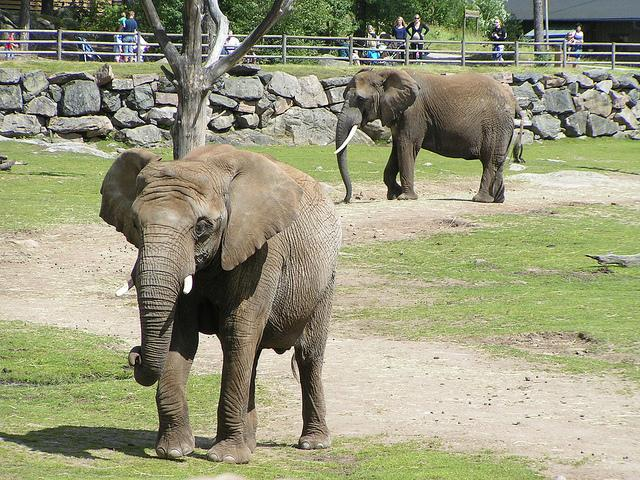At which elevation are the elephants compared to those looking at them?

Choices:
A) same
B) lower
C) changing
D) higher lower 